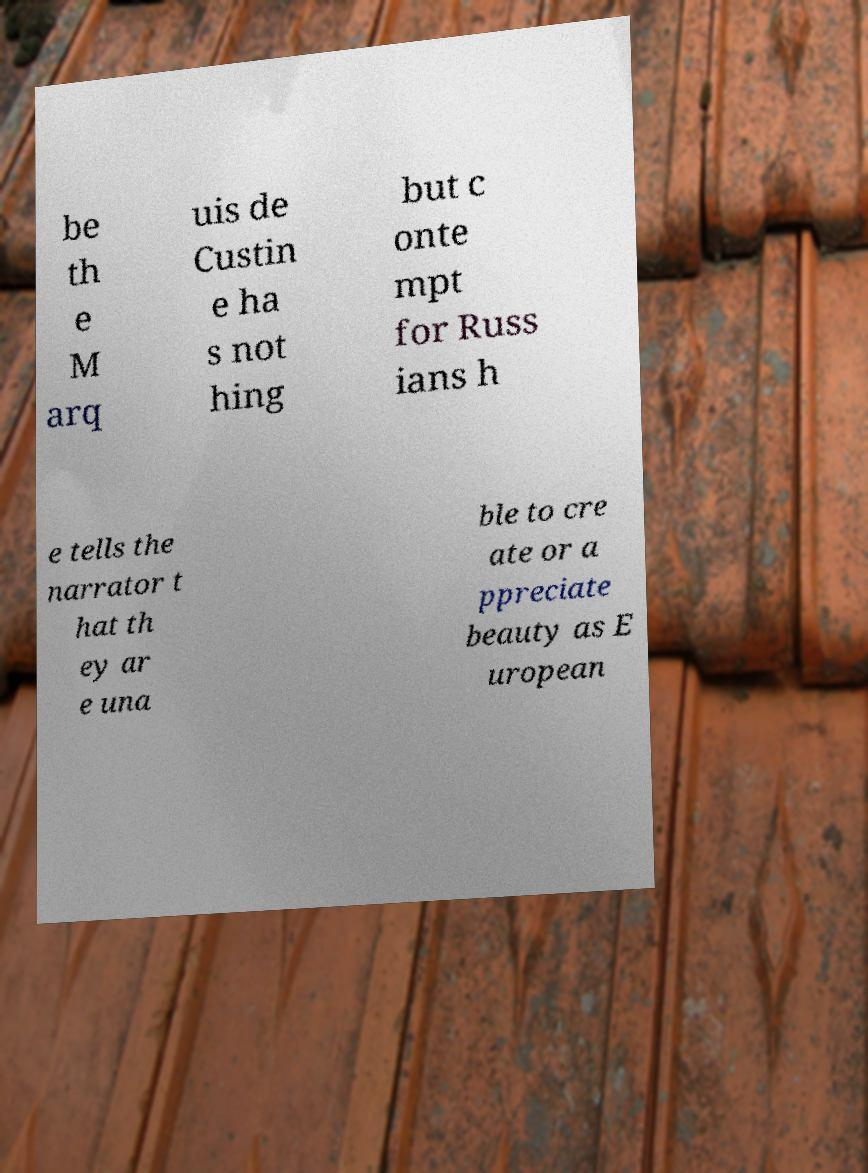For documentation purposes, I need the text within this image transcribed. Could you provide that? be th e M arq uis de Custin e ha s not hing but c onte mpt for Russ ians h e tells the narrator t hat th ey ar e una ble to cre ate or a ppreciate beauty as E uropean 